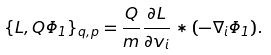<formula> <loc_0><loc_0><loc_500><loc_500>\{ L , Q \Phi _ { 1 } \} _ { { q } , { p } } = \frac { Q } { m } \frac { \partial L } { \partial v _ { i } } * ( - \nabla _ { i } \Phi _ { 1 } ) .</formula> 